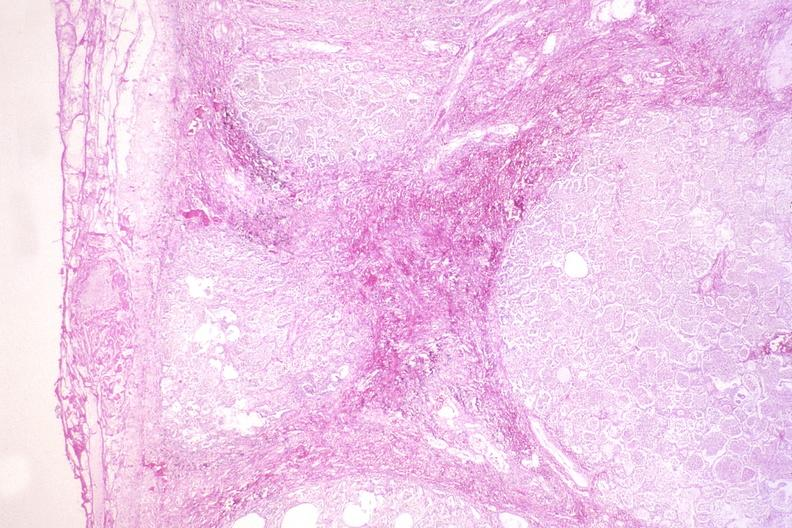does marked show kaposis 's sarcoma in the lung?
Answer the question using a single word or phrase. No 